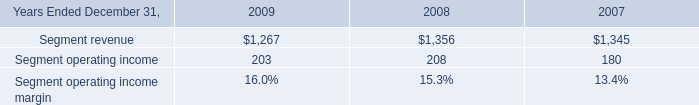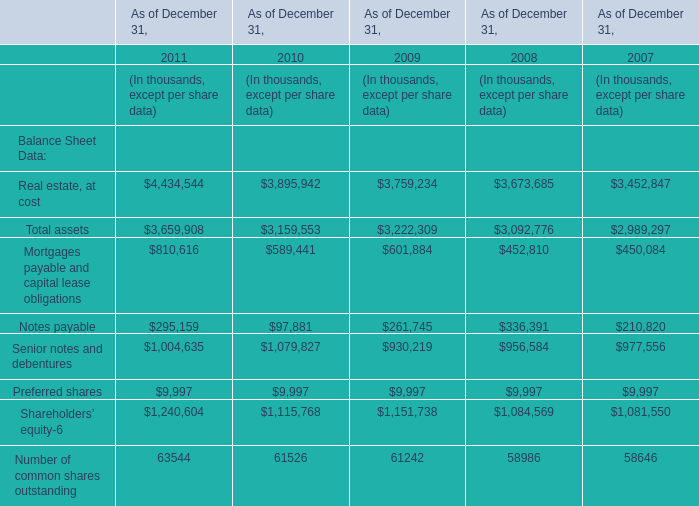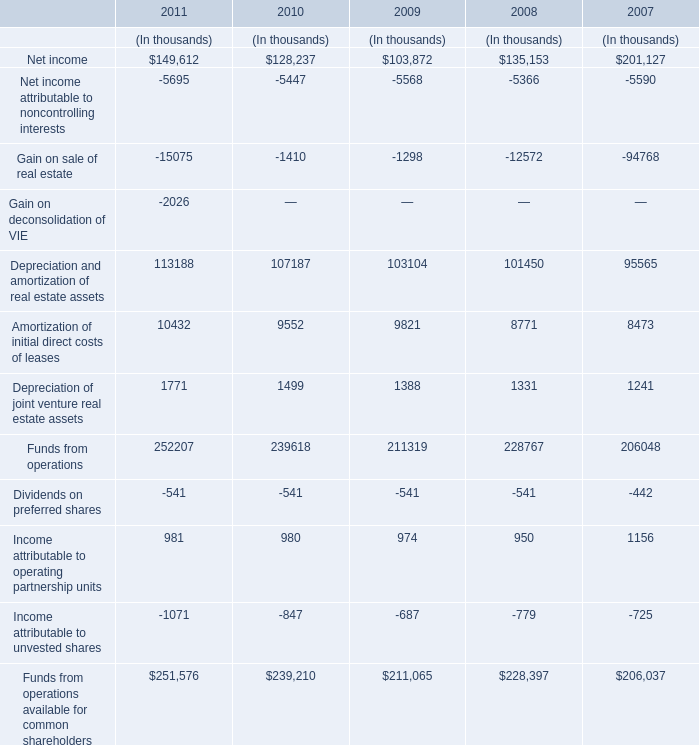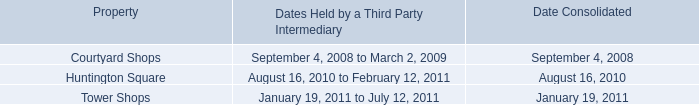what was the total revenues in 2009 based on the consulting segment generated 17% ( 17 % ) of our consolidated total revenues in millions 
Computations: (1267 / 17%)
Answer: 7452.94118. 